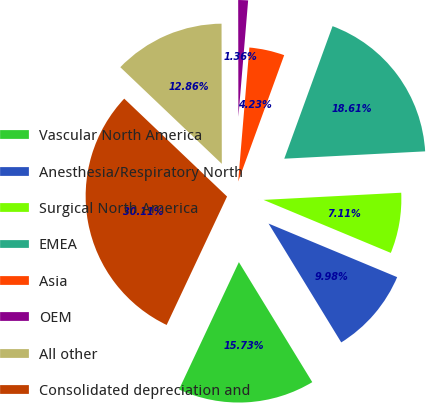Convert chart. <chart><loc_0><loc_0><loc_500><loc_500><pie_chart><fcel>Vascular North America<fcel>Anesthesia/Respiratory North<fcel>Surgical North America<fcel>EMEA<fcel>Asia<fcel>OEM<fcel>All other<fcel>Consolidated depreciation and<nl><fcel>15.73%<fcel>9.98%<fcel>7.11%<fcel>18.61%<fcel>4.23%<fcel>1.36%<fcel>12.86%<fcel>30.11%<nl></chart> 